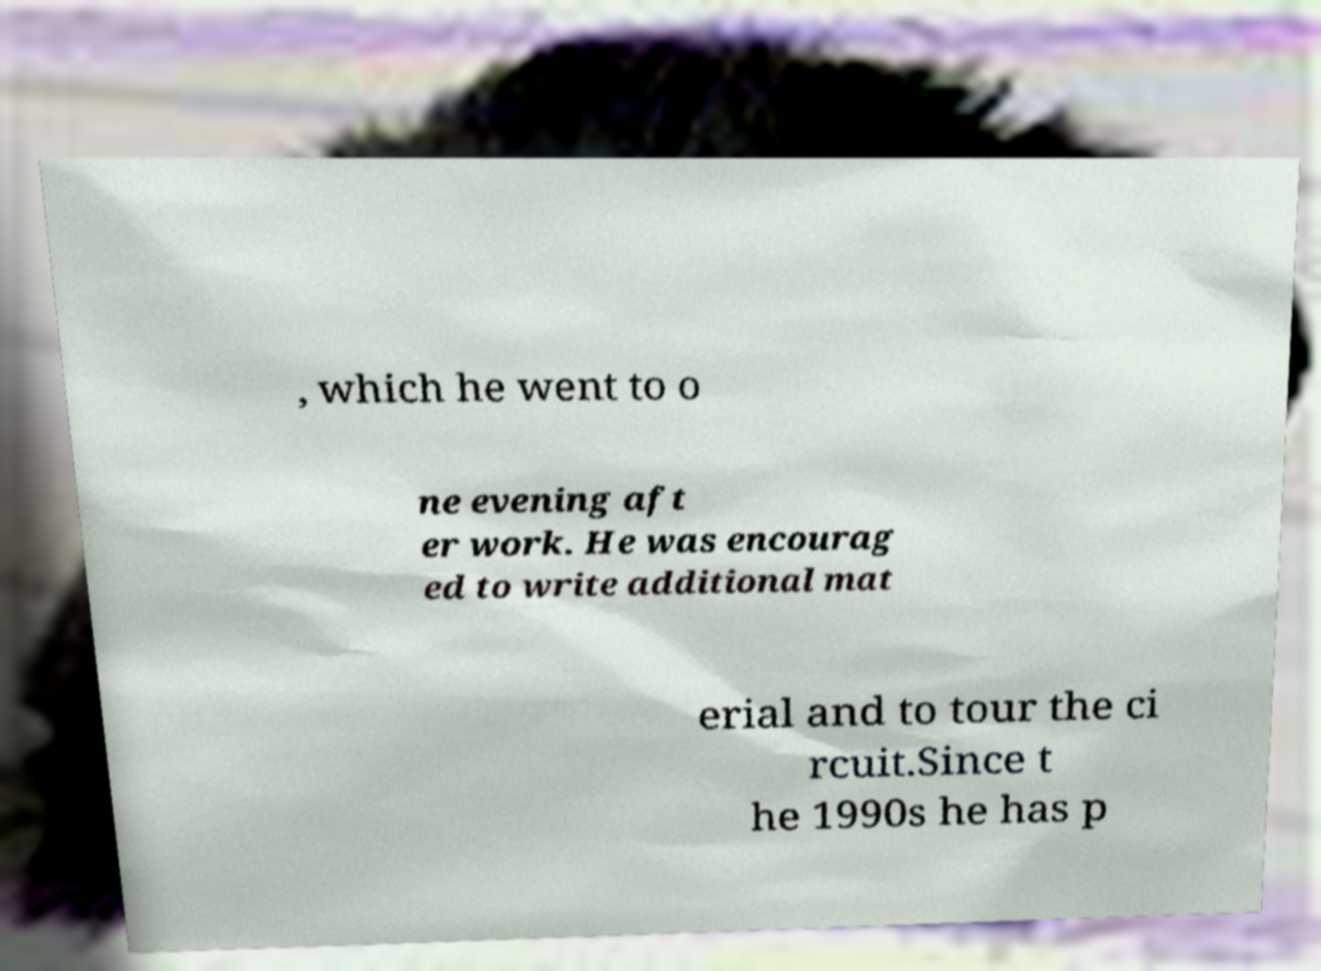Can you read and provide the text displayed in the image?This photo seems to have some interesting text. Can you extract and type it out for me? , which he went to o ne evening aft er work. He was encourag ed to write additional mat erial and to tour the ci rcuit.Since t he 1990s he has p 